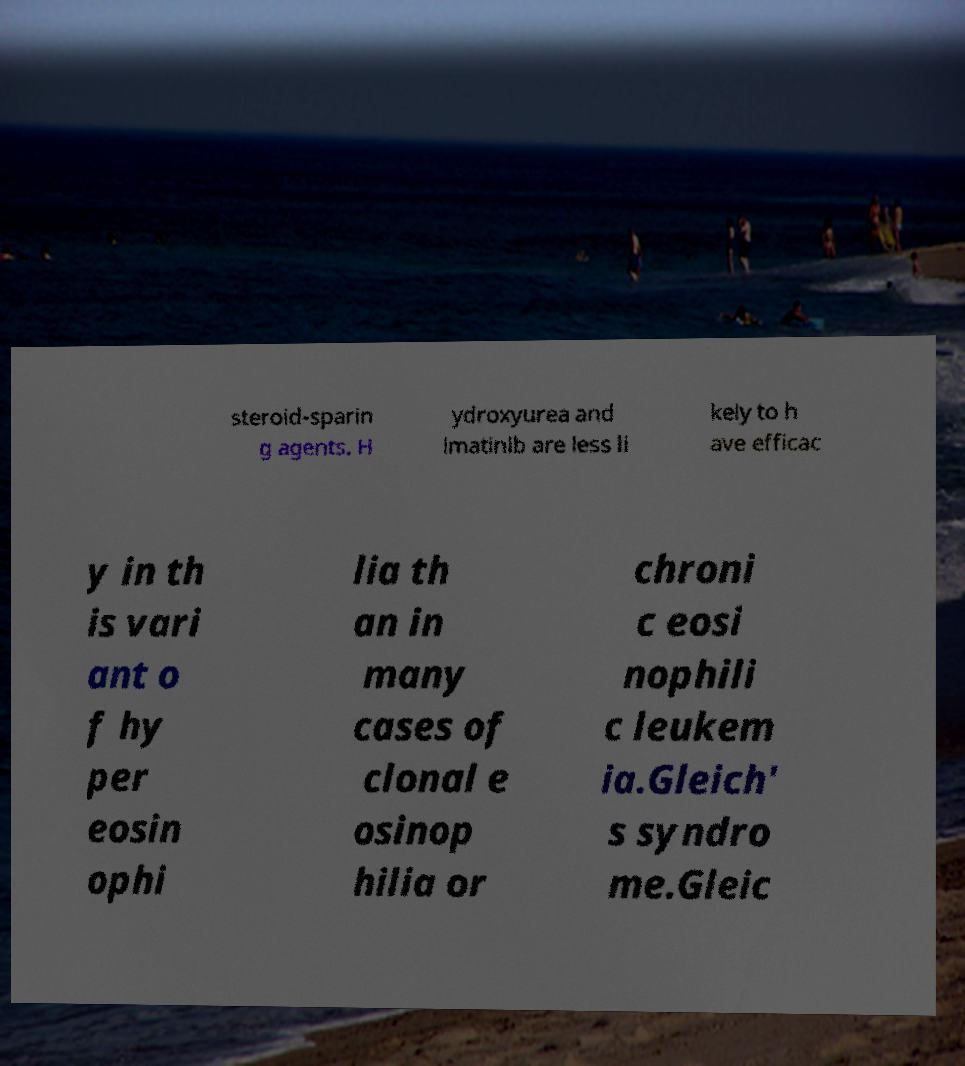Please identify and transcribe the text found in this image. steroid-sparin g agents. H ydroxyurea and imatinib are less li kely to h ave efficac y in th is vari ant o f hy per eosin ophi lia th an in many cases of clonal e osinop hilia or chroni c eosi nophili c leukem ia.Gleich' s syndro me.Gleic 